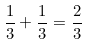<formula> <loc_0><loc_0><loc_500><loc_500>\frac { 1 } { 3 } + \frac { 1 } { 3 } = \frac { 2 } { 3 }</formula> 